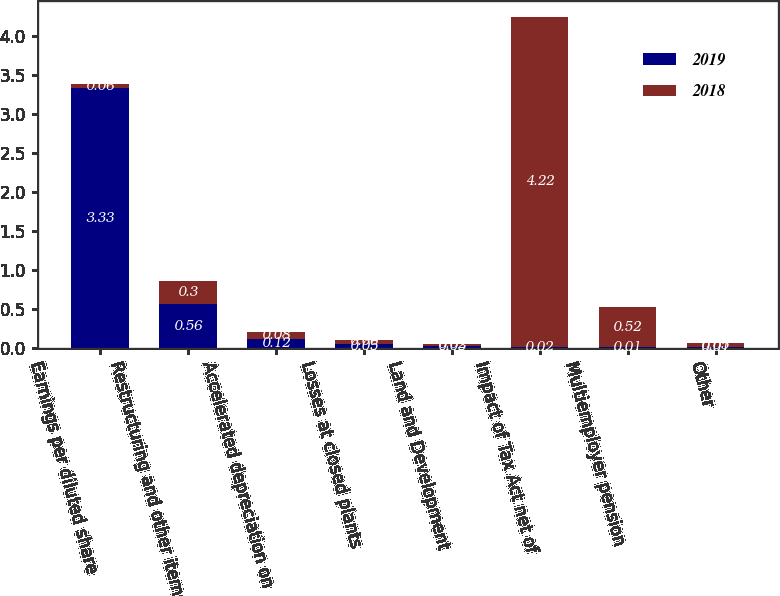Convert chart. <chart><loc_0><loc_0><loc_500><loc_500><stacked_bar_chart><ecel><fcel>Earnings per diluted share<fcel>Restructuring and other items<fcel>Accelerated depreciation on<fcel>Losses at closed plants<fcel>Land and Development<fcel>Impact of Tax Act net of<fcel>Multiemployer pension<fcel>Other<nl><fcel>2019<fcel>3.33<fcel>0.56<fcel>0.12<fcel>0.05<fcel>0.03<fcel>0.02<fcel>0.01<fcel>0.01<nl><fcel>2018<fcel>0.06<fcel>0.3<fcel>0.08<fcel>0.06<fcel>0.02<fcel>4.22<fcel>0.52<fcel>0.05<nl></chart> 